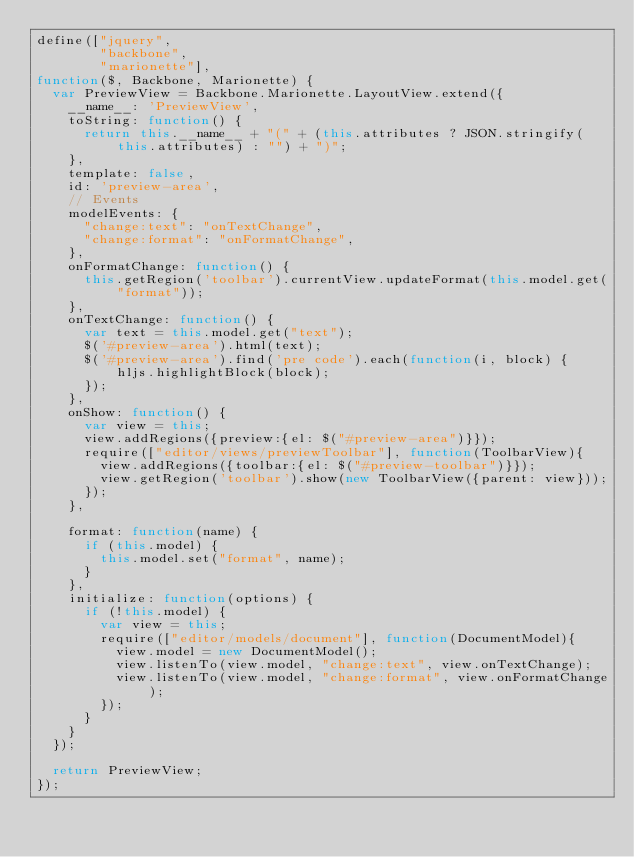Convert code to text. <code><loc_0><loc_0><loc_500><loc_500><_JavaScript_>define(["jquery",
        "backbone",
        "marionette"],
function($, Backbone, Marionette) {
  var PreviewView = Backbone.Marionette.LayoutView.extend({
    __name__: 'PreviewView',
    toString: function() {
      return this.__name__ + "(" + (this.attributes ? JSON.stringify(this.attributes) : "") + ")";
    },
    template: false,
    id: 'preview-area',
    // Events
    modelEvents: {
      "change:text": "onTextChange",
      "change:format": "onFormatChange",
    },
    onFormatChange: function() {
      this.getRegion('toolbar').currentView.updateFormat(this.model.get("format"));
    },
    onTextChange: function() {
      var text = this.model.get("text");
      $('#preview-area').html(text);
      $('#preview-area').find('pre code').each(function(i, block) {
          hljs.highlightBlock(block);
      });
    },
    onShow: function() {
      var view = this;
      view.addRegions({preview:{el: $("#preview-area")}});
      require(["editor/views/previewToolbar"], function(ToolbarView){
        view.addRegions({toolbar:{el: $("#preview-toolbar")}});
        view.getRegion('toolbar').show(new ToolbarView({parent: view}));
      });
    },

    format: function(name) {
      if (this.model) {
        this.model.set("format", name);
      }
    },
    initialize: function(options) {
      if (!this.model) {
        var view = this;
        require(["editor/models/document"], function(DocumentModel){
          view.model = new DocumentModel();
          view.listenTo(view.model, "change:text", view.onTextChange);
          view.listenTo(view.model, "change:format", view.onFormatChange);
        });
      }
    }
  });

  return PreviewView;
});
</code> 